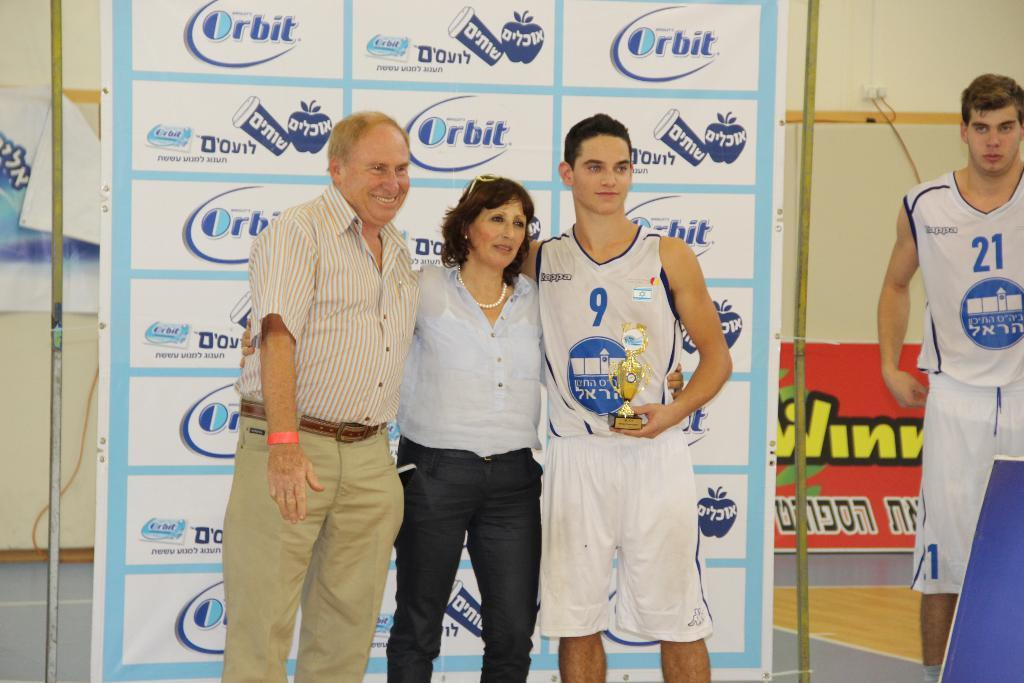Provide a one-sentence caption for the provided image. Player #9 won the MVP award at the basketball game. 